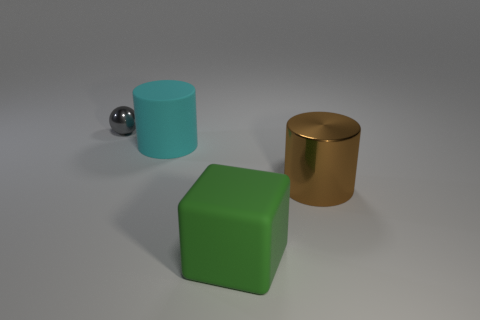Add 1 large red rubber balls. How many objects exist? 5 Subtract all balls. How many objects are left? 3 Subtract 0 purple balls. How many objects are left? 4 Subtract all small yellow matte cylinders. Subtract all big metallic cylinders. How many objects are left? 3 Add 2 large rubber cubes. How many large rubber cubes are left? 3 Add 3 large red cylinders. How many large red cylinders exist? 3 